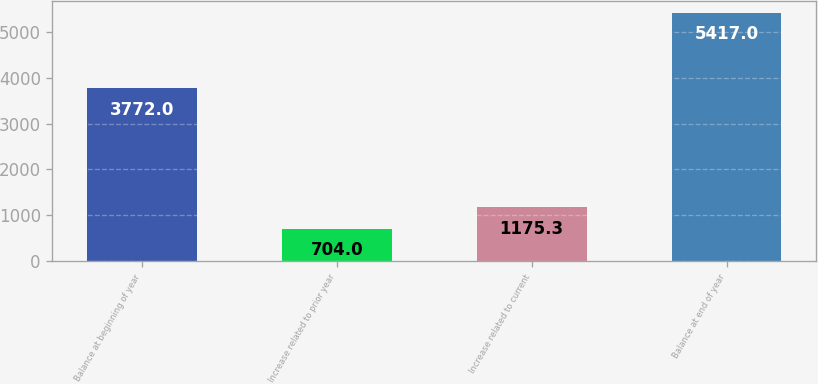Convert chart. <chart><loc_0><loc_0><loc_500><loc_500><bar_chart><fcel>Balance at beginning of year<fcel>Increase related to prior year<fcel>Increase related to current<fcel>Balance at end of year<nl><fcel>3772<fcel>704<fcel>1175.3<fcel>5417<nl></chart> 